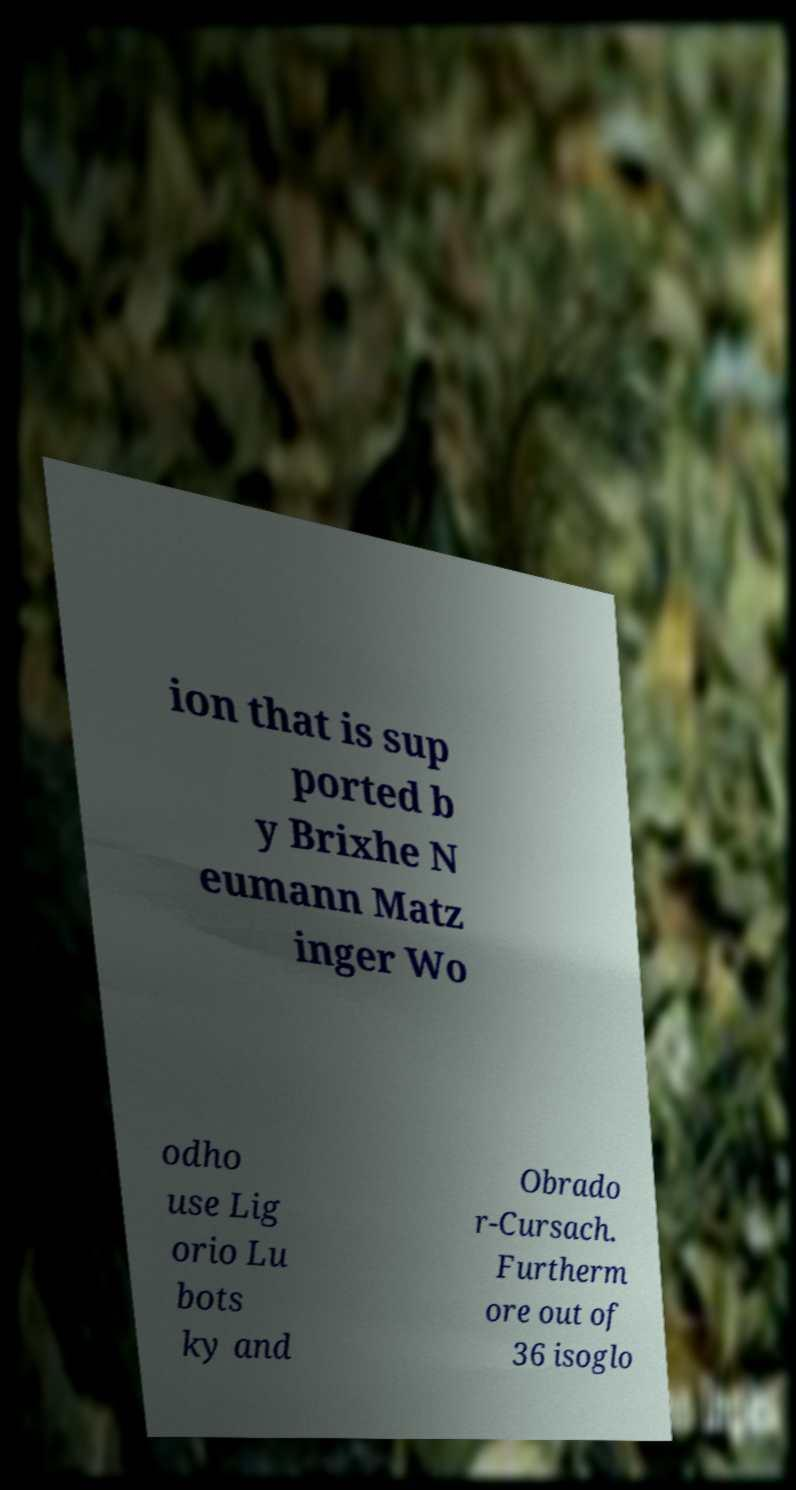For documentation purposes, I need the text within this image transcribed. Could you provide that? ion that is sup ported b y Brixhe N eumann Matz inger Wo odho use Lig orio Lu bots ky and Obrado r-Cursach. Furtherm ore out of 36 isoglo 